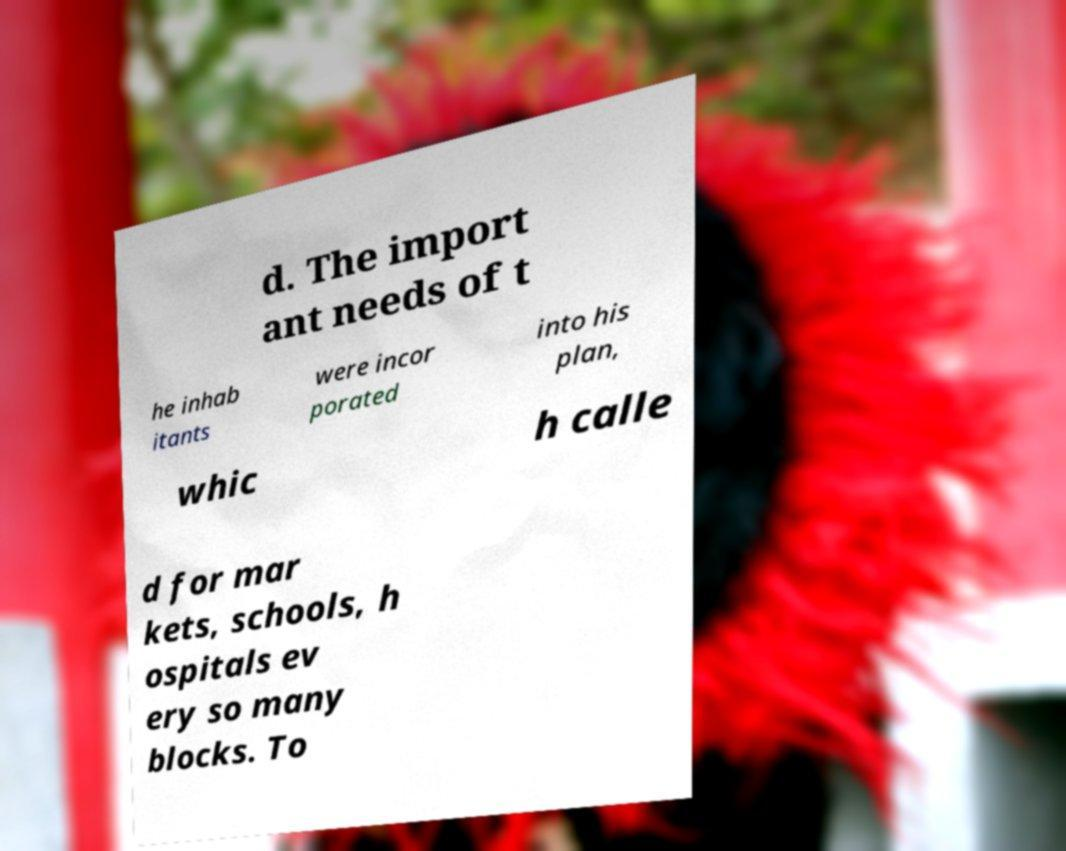Could you extract and type out the text from this image? d. The import ant needs of t he inhab itants were incor porated into his plan, whic h calle d for mar kets, schools, h ospitals ev ery so many blocks. To 